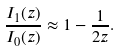Convert formula to latex. <formula><loc_0><loc_0><loc_500><loc_500>\frac { I _ { 1 } ( z ) } { I _ { 0 } ( z ) } \approx 1 - \frac { 1 } { 2 z } .</formula> 